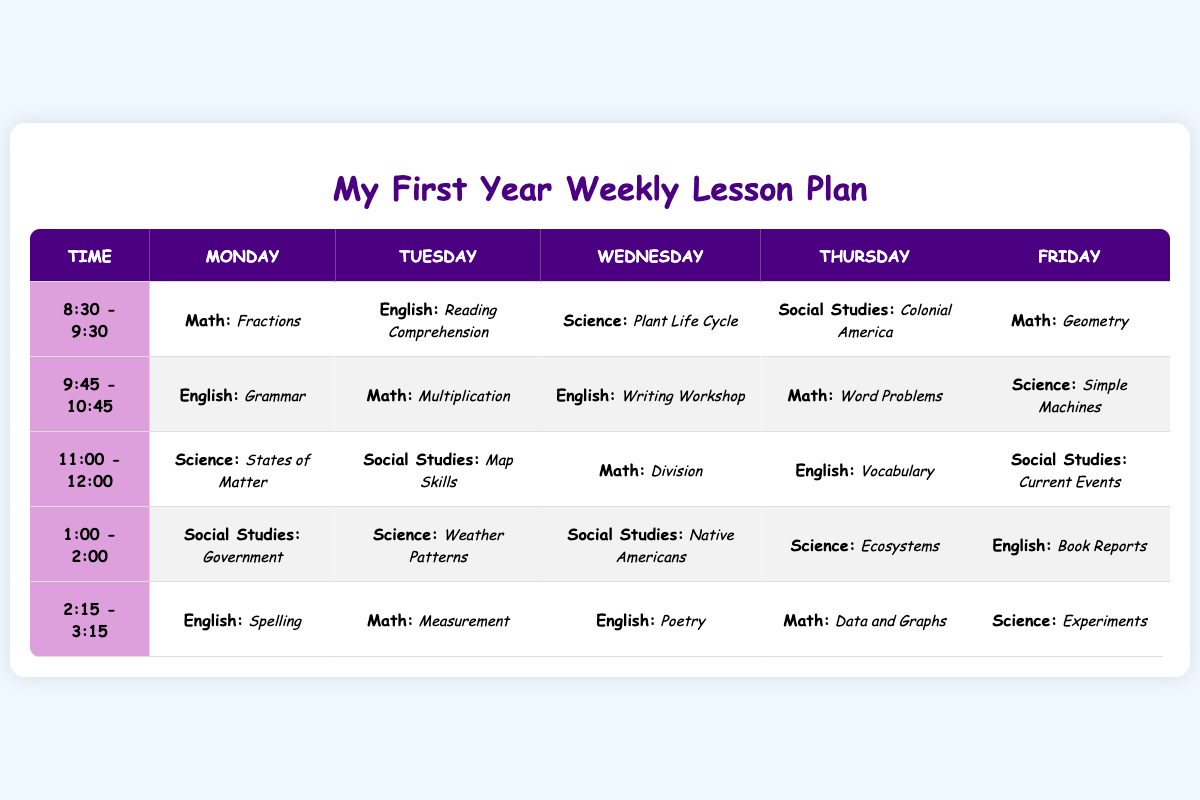What subject is taught during the 11:00 - 12:00 slot on Thursday? The table indicates that during the 11:00 - 12:00 time slot on Thursday, the subject is "English: Vocabulary." You can find this under the column for Thursday corresponding to the specified time.
Answer: English: Vocabulary What is the second subject taught on Tuesday at 9:45 - 10:45? According to the table, on Tuesday at 9:45 - 10:45, the first subject is "Math: Multiplication," making it the second subject in that time slot.
Answer: Math: Multiplication True or False: There are more Science lessons than Social Studies lessons scheduled for the week. By reviewing the table, we count a total of 5 Science lessons and 5 Social Studies lessons. Since both subjects have the same number of lessons, the statement is false.
Answer: False How many different subjects are covered on Monday? Looking at the Monday column, we can identify the subjects: Math, English, Science, Social Studies, and English again. Counting these distinct subjects gives us a total of 4 different subjects since English is repeated.
Answer: 4 What subject occurs most frequently during the 2:15 - 3:15 time slot across the week? In the 2:15 - 3:15 slot, we identify the subjects taught: English: Spelling, Math: Measurement, English: Poetry, Math: Data and Graphs, and Science: Experiments. Here, English and Math both appear twice, making it necessary to consider their repetition separately. Thus, both subjects are tied for frequency.
Answer: English and Math Which day has the most topics related to Math, and how many are there? To find this, we check each day's activities for Math: Monday has 2 (Fractions, Geometry), Tuesday has 2 (Multiplication, Measurement), Wednesday has 2 (Division), Thursday has 2 (Word Problems, Data and Graphs), and Friday has 1 (the total is 9). Thus, no day stands out distinctly as having more topics.
Answer: Each day has 2 or 1 Math topics; none is more than others What lessons are scheduled on Wednesday? The Wednesday column has the following lessons: "Science: Plant Life Cycle," "English: Writing Workshop," "Math: Division," "Social Studies: Native Americans," and "English: Poetry." Collectively, we can thus identify a total of 5 subjects taught specifically on Wednesday.
Answer: 5 lessons True or False: Social Studies is only taught on Tuesdays and Thursdays. By examining the table, Social Studies is taught on Monday, Tuesday, Wednesday, and Thursday, which indicates it is not limited to only Tuesday and Thursday. Therefore, the statement is false.
Answer: False 